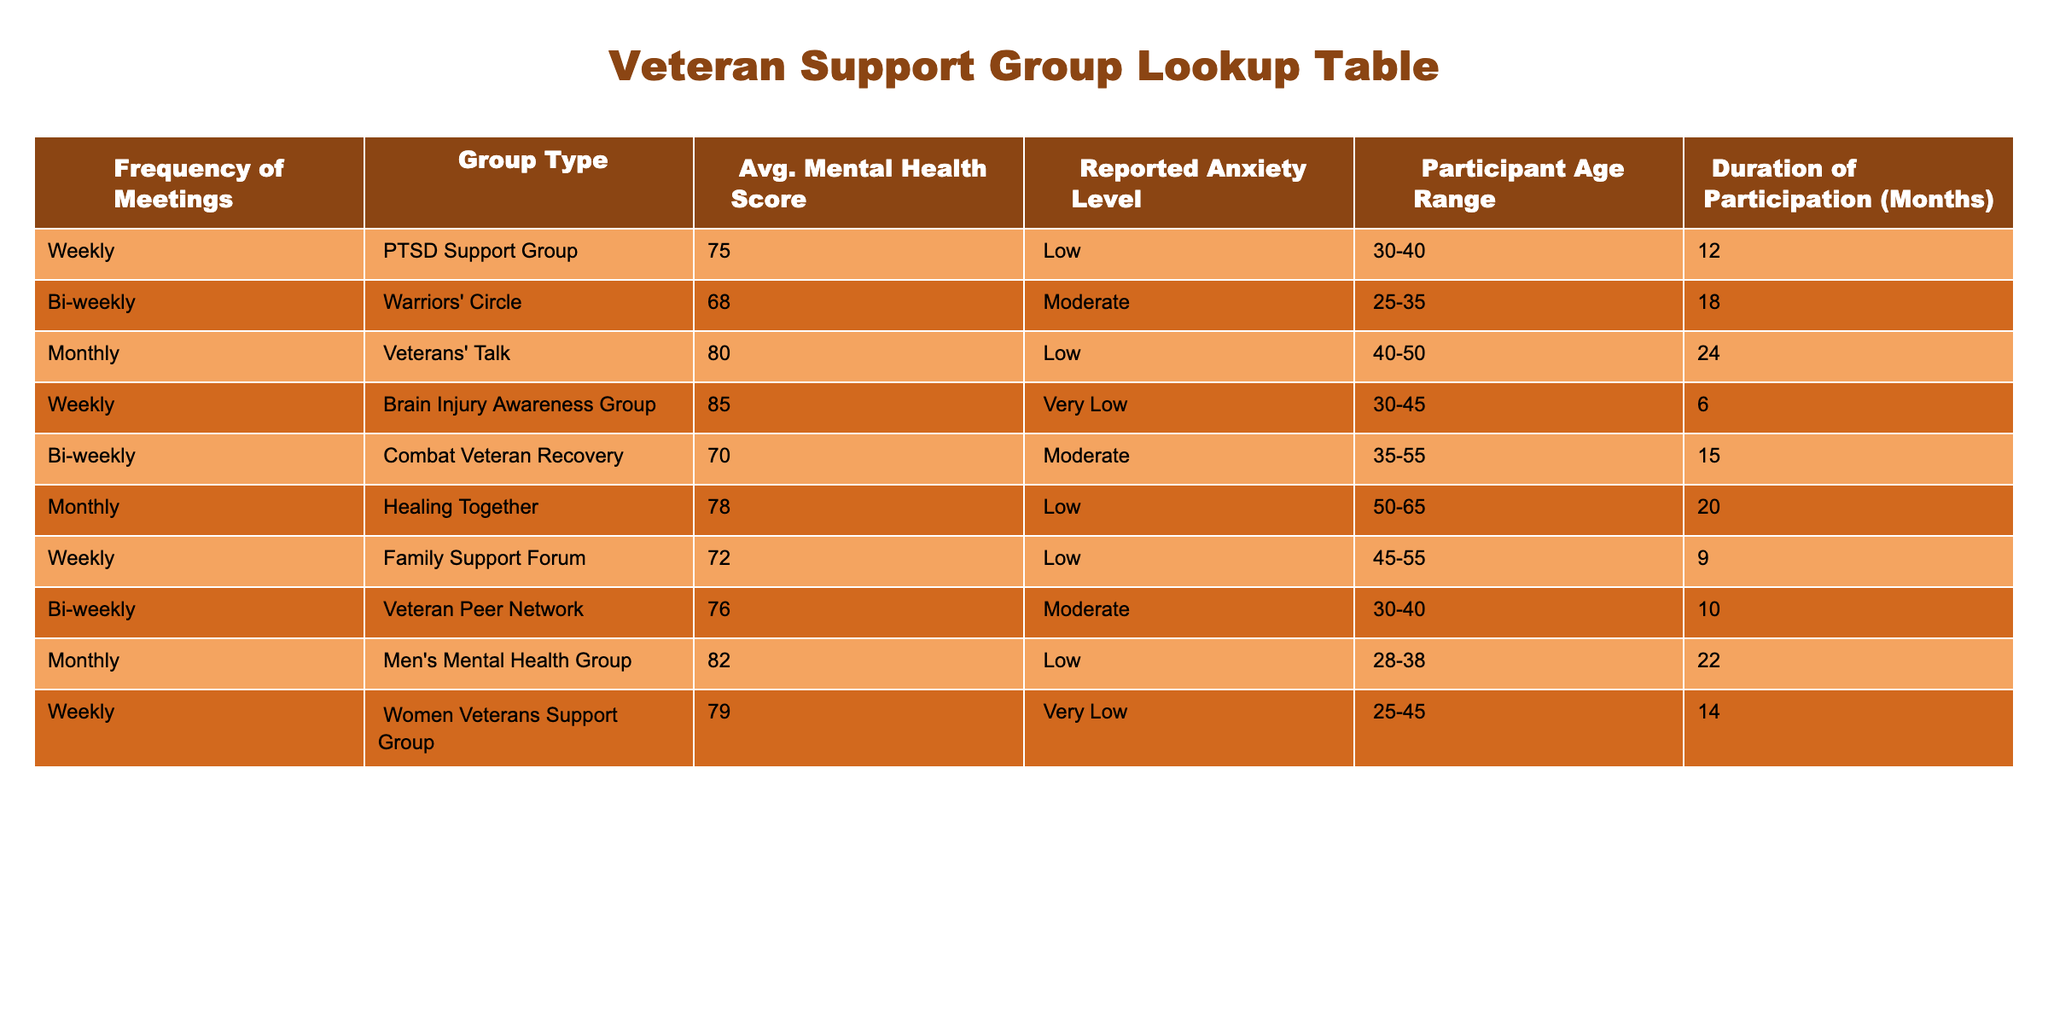What is the average mental health score for the Monthly group type? The Monthly group type has three entries: Veterans' Talk with a score of 80, Healing Together with a score of 78, and Men's Mental Health Group with a score of 82. To find the average, we sum these scores: 80 + 78 + 82 = 240. Then we divide by the number of entries: 240 / 3 = 80.
Answer: 80 Which support group has the lowest reported anxiety level? Looking at the reported anxiety level for each group, the Brain Injury Awareness Group and the Women Veterans Support Group both have "Very Low" anxiety levels. Therefore, either of these two groups can be considered to have the lowest reported anxiety level.
Answer: Brain Injury Awareness Group, Women Veterans Support Group How long did the participants in the Combat Veteran Recovery group stay? The table clearly states that the duration of participation for the Combat Veteran Recovery group is 15 months. This is a straightforward reading of the table.
Answer: 15 months Is there a correlation between the frequency of meetings and average mental health scores? To determine if there's a correlation, we need to observe the meeting frequencies and their average mental health scores: Weekly groups have scores of 75, 85, 72, and 79 (average 77.75), Bi-weekly groups have scores of 68, 70, and 76 (average 71.33), and Monthly groups have scores of 80, 78, and 82 (average 80). The averages do not show a direct correlation as scores do not consistently increase or decrease with frequency.
Answer: No What is the average duration of participation for all groups combined? To find the average duration of participation, we sum the durations: 12 + 18 + 24 + 6 + 15 + 20 + 9 + 10 + 22 + 14 = 120. There are 10 entries, so we divide by 10 to find the average: 120 / 10 = 12.
Answer: 12 months Which age range has the highest average mental health score? We calculate the average mental health scores segmented by age ranges: 30-40 has scores of 75 (PTSD Support Group), 76 (Veteran Peer Network) and 85 (Brain Injury Awareness Group), averaging to (75 + 76 + 85) / 3 = 78.67; 25-35 has 68 (Warriors' Circle) and 79 (Women Veterans Support Group), averaging to (68 + 79) / 2 = 73.5; 40-50 has 80 (Veterans' Talk); 50-65 has 78 (Healing Together); 35-55 has 70 (Combat Veteran Recovery); 45-55 has 72 (Family Support Forum); 28-38 has 82 (Men's Mental Health Group). The highest average occurs in the age range of 40-50 with 80.
Answer: 40-50 Does attending weekly meetings lead to lower reported anxiety levels? We check the anxiety levels for weekly meetings: PTSD Support Group (Low), Brain Injury Awareness Group (Very Low), Family Support Forum (Low), and Women Veterans Support Group (Very Low). Since there are both low and very low levels reported, it cannot be concluded that weekly meetings lead to a consistently lower level of anxiety.
Answer: No 